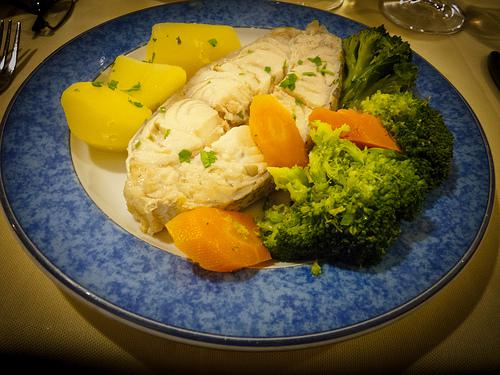Question: what food is farthest right?
Choices:
A. Tomatoes.
B. Cabbage.
C. Broccoli.
D. Bell peppers.
Answer with the letter. Answer: C Question: what vegetable is mixed with broccoli?
Choices:
A. Tomato.
B. Carrot.
C. Cabbage.
D. Onion.
Answer with the letter. Answer: B Question: where is the fish?
Choices:
A. Left from salad.
B. Next to potatoes.
C. Next to vegetables.
D. Center plate.
Answer with the letter. Answer: D Question: where in the photo is the fork?
Choices:
A. On the right.
B. In the back.
C. In the front.
D. On the left.
Answer with the letter. Answer: D Question: what color are the carrots?
Choices:
A. White.
B. Orange.
C. Purple.
D. Yellow.
Answer with the letter. Answer: B 